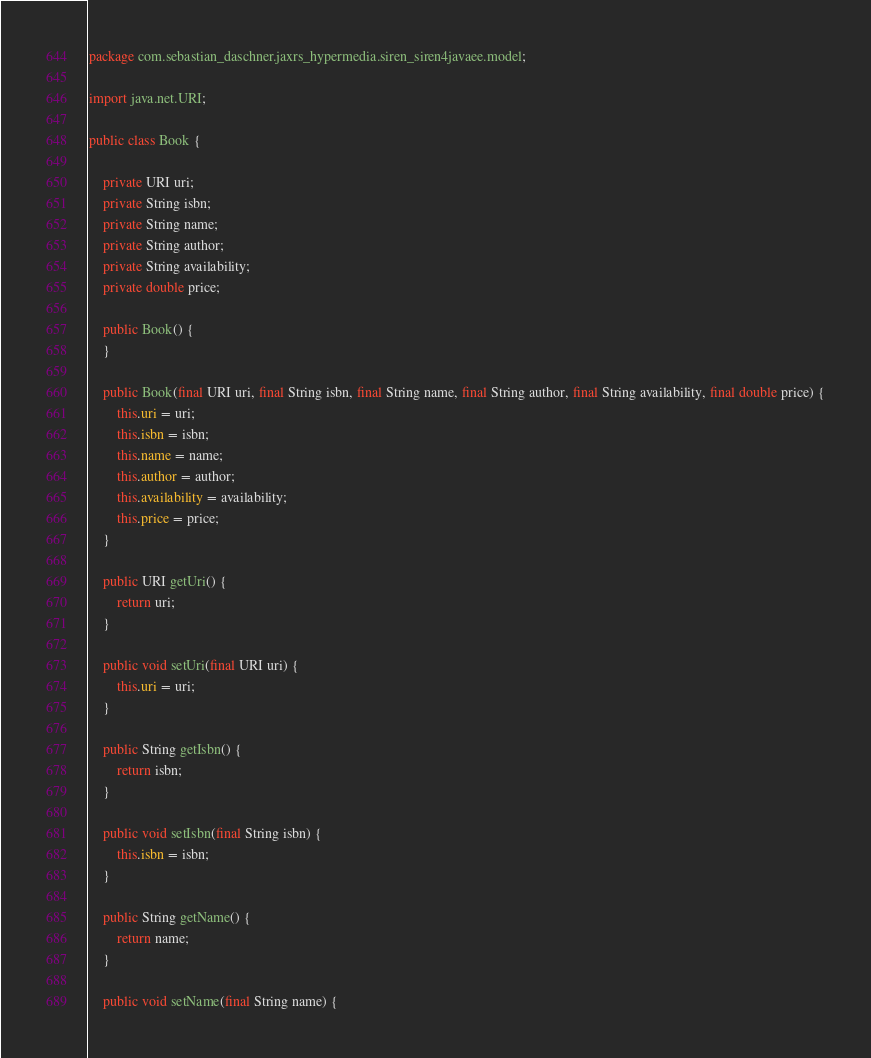<code> <loc_0><loc_0><loc_500><loc_500><_Java_>package com.sebastian_daschner.jaxrs_hypermedia.siren_siren4javaee.model;

import java.net.URI;

public class Book {

    private URI uri;
    private String isbn;
    private String name;
    private String author;
    private String availability;
    private double price;

    public Book() {
    }

    public Book(final URI uri, final String isbn, final String name, final String author, final String availability, final double price) {
        this.uri = uri;
        this.isbn = isbn;
        this.name = name;
        this.author = author;
        this.availability = availability;
        this.price = price;
    }

    public URI getUri() {
        return uri;
    }

    public void setUri(final URI uri) {
        this.uri = uri;
    }

    public String getIsbn() {
        return isbn;
    }

    public void setIsbn(final String isbn) {
        this.isbn = isbn;
    }

    public String getName() {
        return name;
    }

    public void setName(final String name) {</code> 